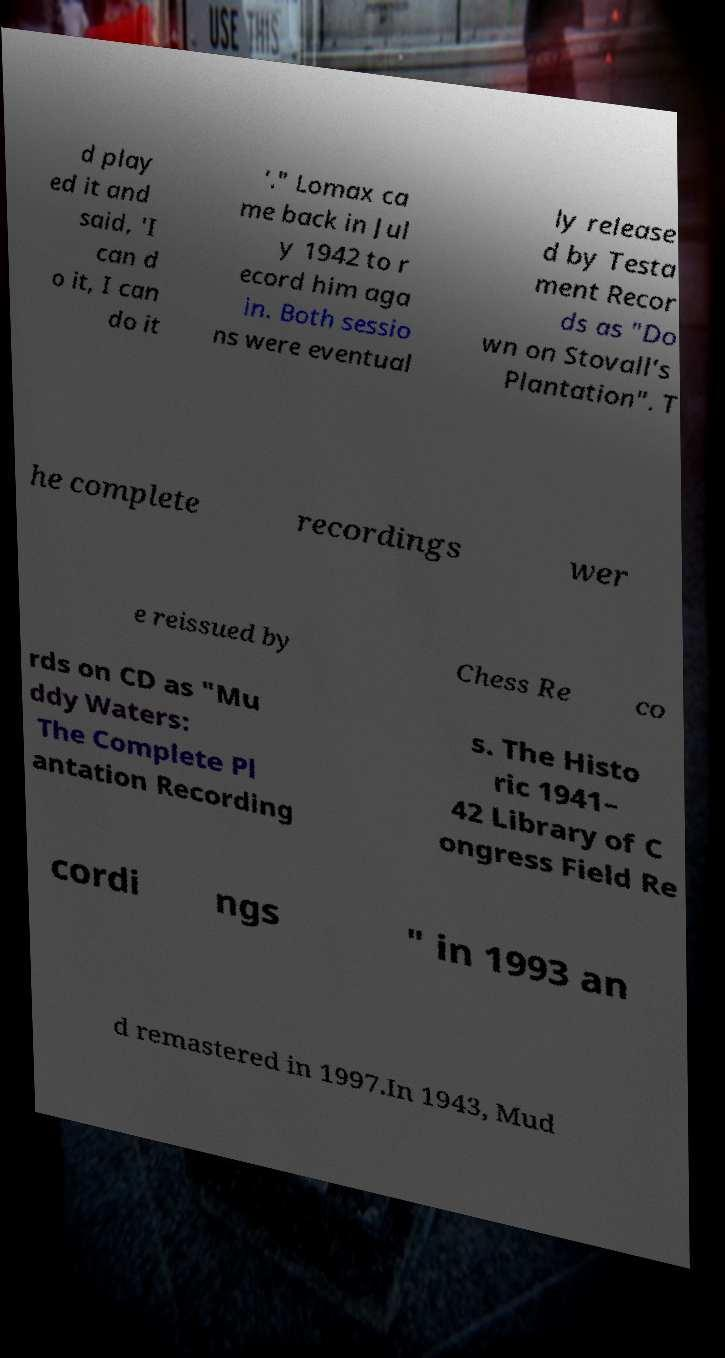There's text embedded in this image that I need extracted. Can you transcribe it verbatim? d play ed it and said, 'I can d o it, I can do it '." Lomax ca me back in Jul y 1942 to r ecord him aga in. Both sessio ns were eventual ly release d by Testa ment Recor ds as "Do wn on Stovall's Plantation". T he complete recordings wer e reissued by Chess Re co rds on CD as "Mu ddy Waters: The Complete Pl antation Recording s. The Histo ric 1941– 42 Library of C ongress Field Re cordi ngs " in 1993 an d remastered in 1997.In 1943, Mud 